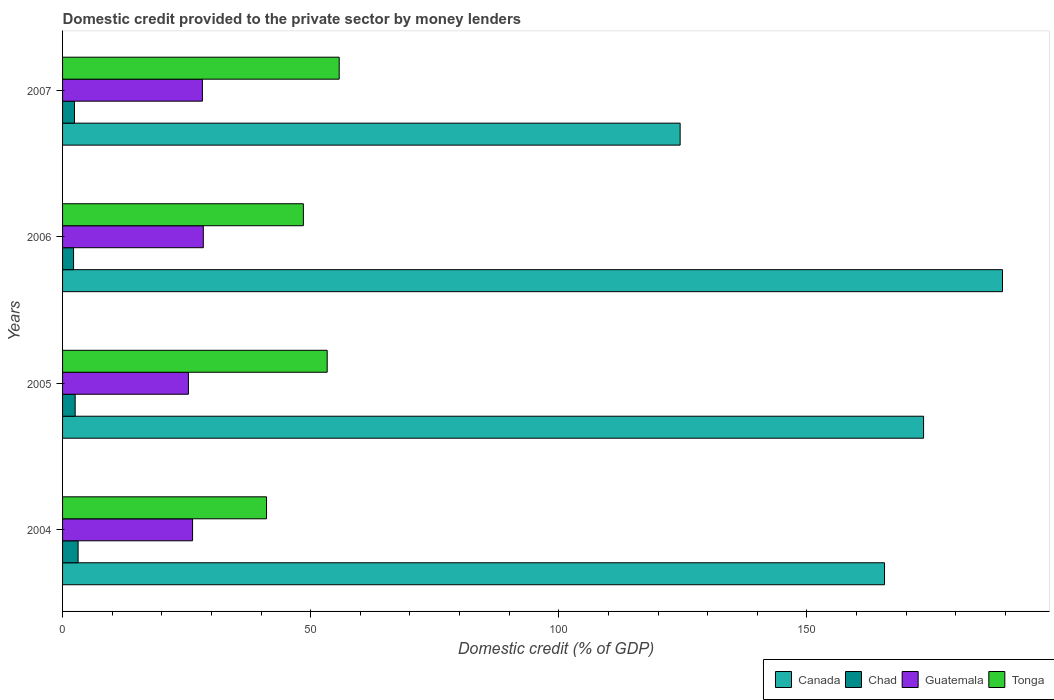How many groups of bars are there?
Ensure brevity in your answer.  4. What is the domestic credit provided to the private sector by money lenders in Chad in 2005?
Give a very brief answer. 2.54. Across all years, what is the maximum domestic credit provided to the private sector by money lenders in Tonga?
Give a very brief answer. 55.75. Across all years, what is the minimum domestic credit provided to the private sector by money lenders in Guatemala?
Provide a succinct answer. 25.36. What is the total domestic credit provided to the private sector by money lenders in Chad in the graph?
Provide a short and direct response. 10.29. What is the difference between the domestic credit provided to the private sector by money lenders in Tonga in 2005 and that in 2007?
Offer a very short reply. -2.42. What is the difference between the domestic credit provided to the private sector by money lenders in Chad in 2006 and the domestic credit provided to the private sector by money lenders in Canada in 2007?
Keep it short and to the point. -122.25. What is the average domestic credit provided to the private sector by money lenders in Guatemala per year?
Your answer should be very brief. 27.03. In the year 2007, what is the difference between the domestic credit provided to the private sector by money lenders in Guatemala and domestic credit provided to the private sector by money lenders in Chad?
Ensure brevity in your answer.  25.79. What is the ratio of the domestic credit provided to the private sector by money lenders in Chad in 2004 to that in 2005?
Provide a short and direct response. 1.23. Is the difference between the domestic credit provided to the private sector by money lenders in Guatemala in 2004 and 2005 greater than the difference between the domestic credit provided to the private sector by money lenders in Chad in 2004 and 2005?
Make the answer very short. Yes. What is the difference between the highest and the second highest domestic credit provided to the private sector by money lenders in Tonga?
Your response must be concise. 2.42. What is the difference between the highest and the lowest domestic credit provided to the private sector by money lenders in Canada?
Give a very brief answer. 64.96. In how many years, is the domestic credit provided to the private sector by money lenders in Guatemala greater than the average domestic credit provided to the private sector by money lenders in Guatemala taken over all years?
Offer a very short reply. 2. Is it the case that in every year, the sum of the domestic credit provided to the private sector by money lenders in Canada and domestic credit provided to the private sector by money lenders in Chad is greater than the sum of domestic credit provided to the private sector by money lenders in Tonga and domestic credit provided to the private sector by money lenders in Guatemala?
Your response must be concise. Yes. What does the 4th bar from the top in 2005 represents?
Offer a terse response. Canada. What does the 2nd bar from the bottom in 2006 represents?
Your answer should be very brief. Chad. How many bars are there?
Ensure brevity in your answer.  16. Are the values on the major ticks of X-axis written in scientific E-notation?
Provide a succinct answer. No. Does the graph contain any zero values?
Your answer should be compact. No. Where does the legend appear in the graph?
Your response must be concise. Bottom right. How many legend labels are there?
Offer a very short reply. 4. How are the legend labels stacked?
Offer a terse response. Horizontal. What is the title of the graph?
Provide a short and direct response. Domestic credit provided to the private sector by money lenders. Does "Finland" appear as one of the legend labels in the graph?
Provide a succinct answer. No. What is the label or title of the X-axis?
Make the answer very short. Domestic credit (% of GDP). What is the Domestic credit (% of GDP) of Canada in 2004?
Give a very brief answer. 165.65. What is the Domestic credit (% of GDP) in Chad in 2004?
Your answer should be compact. 3.13. What is the Domestic credit (% of GDP) of Guatemala in 2004?
Ensure brevity in your answer.  26.2. What is the Domestic credit (% of GDP) of Tonga in 2004?
Provide a short and direct response. 41.11. What is the Domestic credit (% of GDP) in Canada in 2005?
Your answer should be very brief. 173.52. What is the Domestic credit (% of GDP) in Chad in 2005?
Ensure brevity in your answer.  2.54. What is the Domestic credit (% of GDP) of Guatemala in 2005?
Provide a short and direct response. 25.36. What is the Domestic credit (% of GDP) in Tonga in 2005?
Your response must be concise. 53.33. What is the Domestic credit (% of GDP) in Canada in 2006?
Offer a very short reply. 189.43. What is the Domestic credit (% of GDP) of Chad in 2006?
Keep it short and to the point. 2.22. What is the Domestic credit (% of GDP) in Guatemala in 2006?
Your response must be concise. 28.36. What is the Domestic credit (% of GDP) in Tonga in 2006?
Your response must be concise. 48.53. What is the Domestic credit (% of GDP) of Canada in 2007?
Your answer should be very brief. 124.46. What is the Domestic credit (% of GDP) of Chad in 2007?
Your answer should be compact. 2.4. What is the Domestic credit (% of GDP) in Guatemala in 2007?
Make the answer very short. 28.18. What is the Domestic credit (% of GDP) in Tonga in 2007?
Provide a short and direct response. 55.75. Across all years, what is the maximum Domestic credit (% of GDP) of Canada?
Your answer should be very brief. 189.43. Across all years, what is the maximum Domestic credit (% of GDP) in Chad?
Your response must be concise. 3.13. Across all years, what is the maximum Domestic credit (% of GDP) of Guatemala?
Your response must be concise. 28.36. Across all years, what is the maximum Domestic credit (% of GDP) of Tonga?
Keep it short and to the point. 55.75. Across all years, what is the minimum Domestic credit (% of GDP) of Canada?
Your response must be concise. 124.46. Across all years, what is the minimum Domestic credit (% of GDP) in Chad?
Give a very brief answer. 2.22. Across all years, what is the minimum Domestic credit (% of GDP) of Guatemala?
Provide a short and direct response. 25.36. Across all years, what is the minimum Domestic credit (% of GDP) of Tonga?
Provide a succinct answer. 41.11. What is the total Domestic credit (% of GDP) of Canada in the graph?
Provide a succinct answer. 653.06. What is the total Domestic credit (% of GDP) in Chad in the graph?
Ensure brevity in your answer.  10.29. What is the total Domestic credit (% of GDP) in Guatemala in the graph?
Make the answer very short. 108.11. What is the total Domestic credit (% of GDP) of Tonga in the graph?
Keep it short and to the point. 198.72. What is the difference between the Domestic credit (% of GDP) in Canada in 2004 and that in 2005?
Provide a short and direct response. -7.87. What is the difference between the Domestic credit (% of GDP) in Chad in 2004 and that in 2005?
Your answer should be very brief. 0.59. What is the difference between the Domestic credit (% of GDP) of Guatemala in 2004 and that in 2005?
Offer a terse response. 0.84. What is the difference between the Domestic credit (% of GDP) in Tonga in 2004 and that in 2005?
Provide a short and direct response. -12.22. What is the difference between the Domestic credit (% of GDP) in Canada in 2004 and that in 2006?
Your answer should be very brief. -23.77. What is the difference between the Domestic credit (% of GDP) in Chad in 2004 and that in 2006?
Your answer should be compact. 0.92. What is the difference between the Domestic credit (% of GDP) in Guatemala in 2004 and that in 2006?
Keep it short and to the point. -2.16. What is the difference between the Domestic credit (% of GDP) of Tonga in 2004 and that in 2006?
Your answer should be very brief. -7.42. What is the difference between the Domestic credit (% of GDP) in Canada in 2004 and that in 2007?
Your answer should be very brief. 41.19. What is the difference between the Domestic credit (% of GDP) of Chad in 2004 and that in 2007?
Your answer should be very brief. 0.74. What is the difference between the Domestic credit (% of GDP) in Guatemala in 2004 and that in 2007?
Offer a terse response. -1.98. What is the difference between the Domestic credit (% of GDP) in Tonga in 2004 and that in 2007?
Provide a short and direct response. -14.64. What is the difference between the Domestic credit (% of GDP) in Canada in 2005 and that in 2006?
Ensure brevity in your answer.  -15.91. What is the difference between the Domestic credit (% of GDP) of Chad in 2005 and that in 2006?
Ensure brevity in your answer.  0.33. What is the difference between the Domestic credit (% of GDP) of Guatemala in 2005 and that in 2006?
Provide a succinct answer. -3. What is the difference between the Domestic credit (% of GDP) in Tonga in 2005 and that in 2006?
Offer a very short reply. 4.8. What is the difference between the Domestic credit (% of GDP) in Canada in 2005 and that in 2007?
Your response must be concise. 49.06. What is the difference between the Domestic credit (% of GDP) in Chad in 2005 and that in 2007?
Provide a short and direct response. 0.14. What is the difference between the Domestic credit (% of GDP) of Guatemala in 2005 and that in 2007?
Ensure brevity in your answer.  -2.82. What is the difference between the Domestic credit (% of GDP) in Tonga in 2005 and that in 2007?
Your answer should be very brief. -2.42. What is the difference between the Domestic credit (% of GDP) in Canada in 2006 and that in 2007?
Keep it short and to the point. 64.96. What is the difference between the Domestic credit (% of GDP) in Chad in 2006 and that in 2007?
Give a very brief answer. -0.18. What is the difference between the Domestic credit (% of GDP) in Guatemala in 2006 and that in 2007?
Provide a short and direct response. 0.18. What is the difference between the Domestic credit (% of GDP) in Tonga in 2006 and that in 2007?
Your answer should be compact. -7.22. What is the difference between the Domestic credit (% of GDP) in Canada in 2004 and the Domestic credit (% of GDP) in Chad in 2005?
Your answer should be compact. 163.11. What is the difference between the Domestic credit (% of GDP) in Canada in 2004 and the Domestic credit (% of GDP) in Guatemala in 2005?
Your answer should be very brief. 140.29. What is the difference between the Domestic credit (% of GDP) of Canada in 2004 and the Domestic credit (% of GDP) of Tonga in 2005?
Give a very brief answer. 112.32. What is the difference between the Domestic credit (% of GDP) of Chad in 2004 and the Domestic credit (% of GDP) of Guatemala in 2005?
Your answer should be compact. -22.23. What is the difference between the Domestic credit (% of GDP) in Chad in 2004 and the Domestic credit (% of GDP) in Tonga in 2005?
Your answer should be very brief. -50.19. What is the difference between the Domestic credit (% of GDP) of Guatemala in 2004 and the Domestic credit (% of GDP) of Tonga in 2005?
Your response must be concise. -27.13. What is the difference between the Domestic credit (% of GDP) in Canada in 2004 and the Domestic credit (% of GDP) in Chad in 2006?
Keep it short and to the point. 163.44. What is the difference between the Domestic credit (% of GDP) of Canada in 2004 and the Domestic credit (% of GDP) of Guatemala in 2006?
Ensure brevity in your answer.  137.29. What is the difference between the Domestic credit (% of GDP) of Canada in 2004 and the Domestic credit (% of GDP) of Tonga in 2006?
Ensure brevity in your answer.  117.12. What is the difference between the Domestic credit (% of GDP) in Chad in 2004 and the Domestic credit (% of GDP) in Guatemala in 2006?
Provide a short and direct response. -25.23. What is the difference between the Domestic credit (% of GDP) of Chad in 2004 and the Domestic credit (% of GDP) of Tonga in 2006?
Your answer should be very brief. -45.4. What is the difference between the Domestic credit (% of GDP) in Guatemala in 2004 and the Domestic credit (% of GDP) in Tonga in 2006?
Keep it short and to the point. -22.33. What is the difference between the Domestic credit (% of GDP) of Canada in 2004 and the Domestic credit (% of GDP) of Chad in 2007?
Offer a terse response. 163.25. What is the difference between the Domestic credit (% of GDP) of Canada in 2004 and the Domestic credit (% of GDP) of Guatemala in 2007?
Offer a very short reply. 137.47. What is the difference between the Domestic credit (% of GDP) in Canada in 2004 and the Domestic credit (% of GDP) in Tonga in 2007?
Keep it short and to the point. 109.9. What is the difference between the Domestic credit (% of GDP) in Chad in 2004 and the Domestic credit (% of GDP) in Guatemala in 2007?
Give a very brief answer. -25.05. What is the difference between the Domestic credit (% of GDP) in Chad in 2004 and the Domestic credit (% of GDP) in Tonga in 2007?
Keep it short and to the point. -52.62. What is the difference between the Domestic credit (% of GDP) of Guatemala in 2004 and the Domestic credit (% of GDP) of Tonga in 2007?
Provide a succinct answer. -29.55. What is the difference between the Domestic credit (% of GDP) of Canada in 2005 and the Domestic credit (% of GDP) of Chad in 2006?
Your answer should be very brief. 171.3. What is the difference between the Domestic credit (% of GDP) of Canada in 2005 and the Domestic credit (% of GDP) of Guatemala in 2006?
Provide a short and direct response. 145.16. What is the difference between the Domestic credit (% of GDP) of Canada in 2005 and the Domestic credit (% of GDP) of Tonga in 2006?
Your response must be concise. 124.99. What is the difference between the Domestic credit (% of GDP) in Chad in 2005 and the Domestic credit (% of GDP) in Guatemala in 2006?
Make the answer very short. -25.82. What is the difference between the Domestic credit (% of GDP) in Chad in 2005 and the Domestic credit (% of GDP) in Tonga in 2006?
Make the answer very short. -45.99. What is the difference between the Domestic credit (% of GDP) of Guatemala in 2005 and the Domestic credit (% of GDP) of Tonga in 2006?
Your answer should be very brief. -23.17. What is the difference between the Domestic credit (% of GDP) in Canada in 2005 and the Domestic credit (% of GDP) in Chad in 2007?
Give a very brief answer. 171.12. What is the difference between the Domestic credit (% of GDP) in Canada in 2005 and the Domestic credit (% of GDP) in Guatemala in 2007?
Make the answer very short. 145.34. What is the difference between the Domestic credit (% of GDP) of Canada in 2005 and the Domestic credit (% of GDP) of Tonga in 2007?
Your response must be concise. 117.77. What is the difference between the Domestic credit (% of GDP) in Chad in 2005 and the Domestic credit (% of GDP) in Guatemala in 2007?
Make the answer very short. -25.64. What is the difference between the Domestic credit (% of GDP) of Chad in 2005 and the Domestic credit (% of GDP) of Tonga in 2007?
Your answer should be very brief. -53.21. What is the difference between the Domestic credit (% of GDP) in Guatemala in 2005 and the Domestic credit (% of GDP) in Tonga in 2007?
Your response must be concise. -30.39. What is the difference between the Domestic credit (% of GDP) of Canada in 2006 and the Domestic credit (% of GDP) of Chad in 2007?
Your answer should be compact. 187.03. What is the difference between the Domestic credit (% of GDP) in Canada in 2006 and the Domestic credit (% of GDP) in Guatemala in 2007?
Make the answer very short. 161.24. What is the difference between the Domestic credit (% of GDP) in Canada in 2006 and the Domestic credit (% of GDP) in Tonga in 2007?
Give a very brief answer. 133.67. What is the difference between the Domestic credit (% of GDP) in Chad in 2006 and the Domestic credit (% of GDP) in Guatemala in 2007?
Provide a short and direct response. -25.97. What is the difference between the Domestic credit (% of GDP) in Chad in 2006 and the Domestic credit (% of GDP) in Tonga in 2007?
Your answer should be compact. -53.53. What is the difference between the Domestic credit (% of GDP) in Guatemala in 2006 and the Domestic credit (% of GDP) in Tonga in 2007?
Ensure brevity in your answer.  -27.39. What is the average Domestic credit (% of GDP) of Canada per year?
Offer a terse response. 163.26. What is the average Domestic credit (% of GDP) in Chad per year?
Offer a very short reply. 2.57. What is the average Domestic credit (% of GDP) of Guatemala per year?
Offer a very short reply. 27.03. What is the average Domestic credit (% of GDP) of Tonga per year?
Your response must be concise. 49.68. In the year 2004, what is the difference between the Domestic credit (% of GDP) in Canada and Domestic credit (% of GDP) in Chad?
Provide a short and direct response. 162.52. In the year 2004, what is the difference between the Domestic credit (% of GDP) in Canada and Domestic credit (% of GDP) in Guatemala?
Offer a terse response. 139.45. In the year 2004, what is the difference between the Domestic credit (% of GDP) in Canada and Domestic credit (% of GDP) in Tonga?
Make the answer very short. 124.54. In the year 2004, what is the difference between the Domestic credit (% of GDP) of Chad and Domestic credit (% of GDP) of Guatemala?
Provide a short and direct response. -23.07. In the year 2004, what is the difference between the Domestic credit (% of GDP) of Chad and Domestic credit (% of GDP) of Tonga?
Provide a short and direct response. -37.97. In the year 2004, what is the difference between the Domestic credit (% of GDP) in Guatemala and Domestic credit (% of GDP) in Tonga?
Your answer should be compact. -14.91. In the year 2005, what is the difference between the Domestic credit (% of GDP) of Canada and Domestic credit (% of GDP) of Chad?
Ensure brevity in your answer.  170.98. In the year 2005, what is the difference between the Domestic credit (% of GDP) in Canada and Domestic credit (% of GDP) in Guatemala?
Make the answer very short. 148.16. In the year 2005, what is the difference between the Domestic credit (% of GDP) in Canada and Domestic credit (% of GDP) in Tonga?
Your response must be concise. 120.19. In the year 2005, what is the difference between the Domestic credit (% of GDP) in Chad and Domestic credit (% of GDP) in Guatemala?
Give a very brief answer. -22.82. In the year 2005, what is the difference between the Domestic credit (% of GDP) of Chad and Domestic credit (% of GDP) of Tonga?
Offer a very short reply. -50.79. In the year 2005, what is the difference between the Domestic credit (% of GDP) in Guatemala and Domestic credit (% of GDP) in Tonga?
Offer a very short reply. -27.97. In the year 2006, what is the difference between the Domestic credit (% of GDP) in Canada and Domestic credit (% of GDP) in Chad?
Your response must be concise. 187.21. In the year 2006, what is the difference between the Domestic credit (% of GDP) in Canada and Domestic credit (% of GDP) in Guatemala?
Give a very brief answer. 161.06. In the year 2006, what is the difference between the Domestic credit (% of GDP) in Canada and Domestic credit (% of GDP) in Tonga?
Your answer should be compact. 140.89. In the year 2006, what is the difference between the Domestic credit (% of GDP) of Chad and Domestic credit (% of GDP) of Guatemala?
Give a very brief answer. -26.15. In the year 2006, what is the difference between the Domestic credit (% of GDP) in Chad and Domestic credit (% of GDP) in Tonga?
Provide a short and direct response. -46.32. In the year 2006, what is the difference between the Domestic credit (% of GDP) in Guatemala and Domestic credit (% of GDP) in Tonga?
Make the answer very short. -20.17. In the year 2007, what is the difference between the Domestic credit (% of GDP) in Canada and Domestic credit (% of GDP) in Chad?
Give a very brief answer. 122.06. In the year 2007, what is the difference between the Domestic credit (% of GDP) in Canada and Domestic credit (% of GDP) in Guatemala?
Give a very brief answer. 96.28. In the year 2007, what is the difference between the Domestic credit (% of GDP) of Canada and Domestic credit (% of GDP) of Tonga?
Offer a terse response. 68.71. In the year 2007, what is the difference between the Domestic credit (% of GDP) of Chad and Domestic credit (% of GDP) of Guatemala?
Offer a terse response. -25.79. In the year 2007, what is the difference between the Domestic credit (% of GDP) in Chad and Domestic credit (% of GDP) in Tonga?
Your response must be concise. -53.35. In the year 2007, what is the difference between the Domestic credit (% of GDP) of Guatemala and Domestic credit (% of GDP) of Tonga?
Make the answer very short. -27.57. What is the ratio of the Domestic credit (% of GDP) in Canada in 2004 to that in 2005?
Keep it short and to the point. 0.95. What is the ratio of the Domestic credit (% of GDP) of Chad in 2004 to that in 2005?
Your answer should be compact. 1.23. What is the ratio of the Domestic credit (% of GDP) in Guatemala in 2004 to that in 2005?
Your response must be concise. 1.03. What is the ratio of the Domestic credit (% of GDP) in Tonga in 2004 to that in 2005?
Provide a succinct answer. 0.77. What is the ratio of the Domestic credit (% of GDP) in Canada in 2004 to that in 2006?
Your answer should be compact. 0.87. What is the ratio of the Domestic credit (% of GDP) in Chad in 2004 to that in 2006?
Offer a terse response. 1.41. What is the ratio of the Domestic credit (% of GDP) in Guatemala in 2004 to that in 2006?
Your answer should be compact. 0.92. What is the ratio of the Domestic credit (% of GDP) in Tonga in 2004 to that in 2006?
Offer a very short reply. 0.85. What is the ratio of the Domestic credit (% of GDP) of Canada in 2004 to that in 2007?
Keep it short and to the point. 1.33. What is the ratio of the Domestic credit (% of GDP) of Chad in 2004 to that in 2007?
Offer a very short reply. 1.31. What is the ratio of the Domestic credit (% of GDP) in Guatemala in 2004 to that in 2007?
Offer a terse response. 0.93. What is the ratio of the Domestic credit (% of GDP) of Tonga in 2004 to that in 2007?
Provide a short and direct response. 0.74. What is the ratio of the Domestic credit (% of GDP) of Canada in 2005 to that in 2006?
Ensure brevity in your answer.  0.92. What is the ratio of the Domestic credit (% of GDP) in Chad in 2005 to that in 2006?
Your answer should be compact. 1.15. What is the ratio of the Domestic credit (% of GDP) of Guatemala in 2005 to that in 2006?
Offer a terse response. 0.89. What is the ratio of the Domestic credit (% of GDP) of Tonga in 2005 to that in 2006?
Provide a succinct answer. 1.1. What is the ratio of the Domestic credit (% of GDP) of Canada in 2005 to that in 2007?
Provide a succinct answer. 1.39. What is the ratio of the Domestic credit (% of GDP) in Chad in 2005 to that in 2007?
Make the answer very short. 1.06. What is the ratio of the Domestic credit (% of GDP) of Guatemala in 2005 to that in 2007?
Provide a succinct answer. 0.9. What is the ratio of the Domestic credit (% of GDP) of Tonga in 2005 to that in 2007?
Offer a very short reply. 0.96. What is the ratio of the Domestic credit (% of GDP) in Canada in 2006 to that in 2007?
Keep it short and to the point. 1.52. What is the ratio of the Domestic credit (% of GDP) in Chad in 2006 to that in 2007?
Ensure brevity in your answer.  0.92. What is the ratio of the Domestic credit (% of GDP) in Guatemala in 2006 to that in 2007?
Ensure brevity in your answer.  1.01. What is the ratio of the Domestic credit (% of GDP) in Tonga in 2006 to that in 2007?
Your answer should be compact. 0.87. What is the difference between the highest and the second highest Domestic credit (% of GDP) of Canada?
Keep it short and to the point. 15.91. What is the difference between the highest and the second highest Domestic credit (% of GDP) of Chad?
Offer a terse response. 0.59. What is the difference between the highest and the second highest Domestic credit (% of GDP) of Guatemala?
Keep it short and to the point. 0.18. What is the difference between the highest and the second highest Domestic credit (% of GDP) of Tonga?
Ensure brevity in your answer.  2.42. What is the difference between the highest and the lowest Domestic credit (% of GDP) of Canada?
Give a very brief answer. 64.96. What is the difference between the highest and the lowest Domestic credit (% of GDP) of Chad?
Provide a short and direct response. 0.92. What is the difference between the highest and the lowest Domestic credit (% of GDP) in Guatemala?
Offer a terse response. 3. What is the difference between the highest and the lowest Domestic credit (% of GDP) of Tonga?
Offer a very short reply. 14.64. 